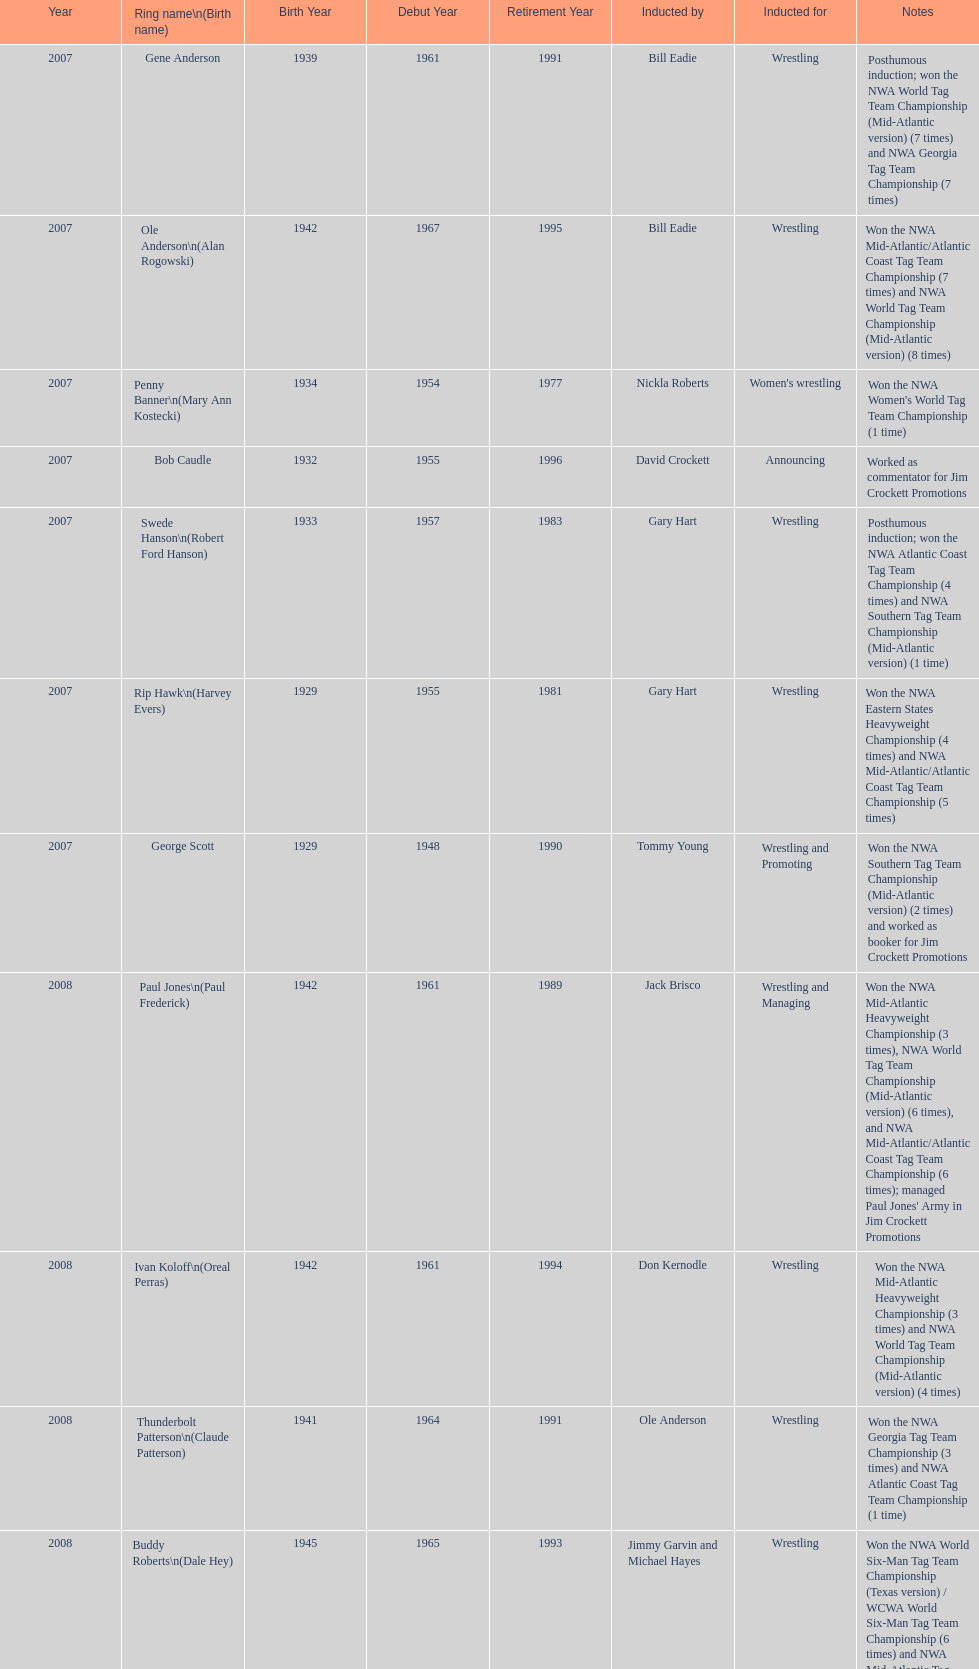Who was the only person to be inducted for wrestling and managing? Paul Jones. 